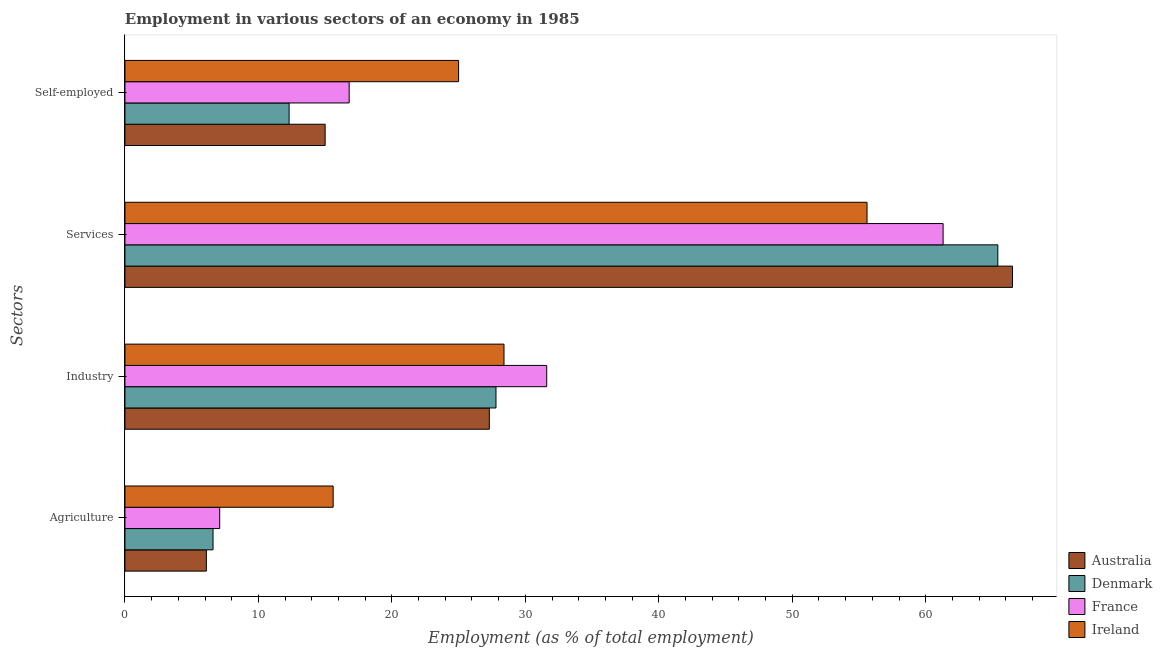How many different coloured bars are there?
Your answer should be very brief. 4. Are the number of bars per tick equal to the number of legend labels?
Make the answer very short. Yes. How many bars are there on the 2nd tick from the bottom?
Your response must be concise. 4. What is the label of the 3rd group of bars from the top?
Give a very brief answer. Industry. What is the percentage of self employed workers in Ireland?
Your answer should be very brief. 25. Across all countries, what is the maximum percentage of workers in services?
Give a very brief answer. 66.5. Across all countries, what is the minimum percentage of workers in services?
Keep it short and to the point. 55.6. What is the total percentage of workers in services in the graph?
Ensure brevity in your answer.  248.8. What is the difference between the percentage of workers in services in France and that in Australia?
Ensure brevity in your answer.  -5.2. What is the difference between the percentage of workers in industry in France and the percentage of workers in services in Denmark?
Provide a succinct answer. -33.8. What is the average percentage of workers in agriculture per country?
Your response must be concise. 8.85. What is the difference between the percentage of workers in services and percentage of workers in agriculture in Denmark?
Provide a succinct answer. 58.8. In how many countries, is the percentage of workers in industry greater than 30 %?
Offer a very short reply. 1. What is the ratio of the percentage of self employed workers in Ireland to that in France?
Make the answer very short. 1.49. What is the difference between the highest and the second highest percentage of self employed workers?
Offer a very short reply. 8.2. What is the difference between the highest and the lowest percentage of workers in agriculture?
Ensure brevity in your answer.  9.5. Is the sum of the percentage of workers in agriculture in Ireland and Australia greater than the maximum percentage of workers in industry across all countries?
Provide a succinct answer. No. Is it the case that in every country, the sum of the percentage of workers in industry and percentage of self employed workers is greater than the sum of percentage of workers in agriculture and percentage of workers in services?
Make the answer very short. No. What does the 3rd bar from the top in Industry represents?
Keep it short and to the point. Denmark. What does the 1st bar from the bottom in Agriculture represents?
Your answer should be compact. Australia. Is it the case that in every country, the sum of the percentage of workers in agriculture and percentage of workers in industry is greater than the percentage of workers in services?
Give a very brief answer. No. Are the values on the major ticks of X-axis written in scientific E-notation?
Keep it short and to the point. No. Does the graph contain any zero values?
Provide a succinct answer. No. Does the graph contain grids?
Your answer should be very brief. No. Where does the legend appear in the graph?
Your response must be concise. Bottom right. How many legend labels are there?
Keep it short and to the point. 4. How are the legend labels stacked?
Provide a succinct answer. Vertical. What is the title of the graph?
Your answer should be compact. Employment in various sectors of an economy in 1985. Does "Belize" appear as one of the legend labels in the graph?
Your answer should be compact. No. What is the label or title of the X-axis?
Your answer should be very brief. Employment (as % of total employment). What is the label or title of the Y-axis?
Offer a terse response. Sectors. What is the Employment (as % of total employment) in Australia in Agriculture?
Offer a terse response. 6.1. What is the Employment (as % of total employment) in Denmark in Agriculture?
Give a very brief answer. 6.6. What is the Employment (as % of total employment) of France in Agriculture?
Provide a succinct answer. 7.1. What is the Employment (as % of total employment) in Ireland in Agriculture?
Your response must be concise. 15.6. What is the Employment (as % of total employment) in Australia in Industry?
Offer a terse response. 27.3. What is the Employment (as % of total employment) in Denmark in Industry?
Provide a succinct answer. 27.8. What is the Employment (as % of total employment) of France in Industry?
Provide a short and direct response. 31.6. What is the Employment (as % of total employment) of Ireland in Industry?
Offer a terse response. 28.4. What is the Employment (as % of total employment) of Australia in Services?
Provide a short and direct response. 66.5. What is the Employment (as % of total employment) of Denmark in Services?
Give a very brief answer. 65.4. What is the Employment (as % of total employment) in France in Services?
Offer a terse response. 61.3. What is the Employment (as % of total employment) in Ireland in Services?
Ensure brevity in your answer.  55.6. What is the Employment (as % of total employment) in Australia in Self-employed?
Provide a short and direct response. 15. What is the Employment (as % of total employment) of Denmark in Self-employed?
Give a very brief answer. 12.3. What is the Employment (as % of total employment) in France in Self-employed?
Provide a short and direct response. 16.8. Across all Sectors, what is the maximum Employment (as % of total employment) in Australia?
Your answer should be very brief. 66.5. Across all Sectors, what is the maximum Employment (as % of total employment) of Denmark?
Keep it short and to the point. 65.4. Across all Sectors, what is the maximum Employment (as % of total employment) of France?
Provide a short and direct response. 61.3. Across all Sectors, what is the maximum Employment (as % of total employment) of Ireland?
Your answer should be very brief. 55.6. Across all Sectors, what is the minimum Employment (as % of total employment) of Australia?
Keep it short and to the point. 6.1. Across all Sectors, what is the minimum Employment (as % of total employment) of Denmark?
Ensure brevity in your answer.  6.6. Across all Sectors, what is the minimum Employment (as % of total employment) of France?
Offer a very short reply. 7.1. Across all Sectors, what is the minimum Employment (as % of total employment) in Ireland?
Make the answer very short. 15.6. What is the total Employment (as % of total employment) in Australia in the graph?
Offer a terse response. 114.9. What is the total Employment (as % of total employment) in Denmark in the graph?
Give a very brief answer. 112.1. What is the total Employment (as % of total employment) of France in the graph?
Provide a succinct answer. 116.8. What is the total Employment (as % of total employment) of Ireland in the graph?
Your answer should be compact. 124.6. What is the difference between the Employment (as % of total employment) in Australia in Agriculture and that in Industry?
Keep it short and to the point. -21.2. What is the difference between the Employment (as % of total employment) of Denmark in Agriculture and that in Industry?
Ensure brevity in your answer.  -21.2. What is the difference between the Employment (as % of total employment) in France in Agriculture and that in Industry?
Ensure brevity in your answer.  -24.5. What is the difference between the Employment (as % of total employment) of Australia in Agriculture and that in Services?
Make the answer very short. -60.4. What is the difference between the Employment (as % of total employment) of Denmark in Agriculture and that in Services?
Provide a short and direct response. -58.8. What is the difference between the Employment (as % of total employment) of France in Agriculture and that in Services?
Your answer should be very brief. -54.2. What is the difference between the Employment (as % of total employment) of Ireland in Agriculture and that in Services?
Make the answer very short. -40. What is the difference between the Employment (as % of total employment) of Australia in Agriculture and that in Self-employed?
Give a very brief answer. -8.9. What is the difference between the Employment (as % of total employment) in Australia in Industry and that in Services?
Offer a terse response. -39.2. What is the difference between the Employment (as % of total employment) in Denmark in Industry and that in Services?
Offer a terse response. -37.6. What is the difference between the Employment (as % of total employment) of France in Industry and that in Services?
Give a very brief answer. -29.7. What is the difference between the Employment (as % of total employment) of Ireland in Industry and that in Services?
Give a very brief answer. -27.2. What is the difference between the Employment (as % of total employment) of Denmark in Industry and that in Self-employed?
Ensure brevity in your answer.  15.5. What is the difference between the Employment (as % of total employment) in Australia in Services and that in Self-employed?
Your answer should be very brief. 51.5. What is the difference between the Employment (as % of total employment) of Denmark in Services and that in Self-employed?
Your answer should be compact. 53.1. What is the difference between the Employment (as % of total employment) of France in Services and that in Self-employed?
Provide a short and direct response. 44.5. What is the difference between the Employment (as % of total employment) of Ireland in Services and that in Self-employed?
Provide a succinct answer. 30.6. What is the difference between the Employment (as % of total employment) of Australia in Agriculture and the Employment (as % of total employment) of Denmark in Industry?
Provide a succinct answer. -21.7. What is the difference between the Employment (as % of total employment) in Australia in Agriculture and the Employment (as % of total employment) in France in Industry?
Your answer should be compact. -25.5. What is the difference between the Employment (as % of total employment) of Australia in Agriculture and the Employment (as % of total employment) of Ireland in Industry?
Offer a very short reply. -22.3. What is the difference between the Employment (as % of total employment) in Denmark in Agriculture and the Employment (as % of total employment) in Ireland in Industry?
Your answer should be compact. -21.8. What is the difference between the Employment (as % of total employment) of France in Agriculture and the Employment (as % of total employment) of Ireland in Industry?
Your answer should be compact. -21.3. What is the difference between the Employment (as % of total employment) of Australia in Agriculture and the Employment (as % of total employment) of Denmark in Services?
Make the answer very short. -59.3. What is the difference between the Employment (as % of total employment) of Australia in Agriculture and the Employment (as % of total employment) of France in Services?
Provide a succinct answer. -55.2. What is the difference between the Employment (as % of total employment) in Australia in Agriculture and the Employment (as % of total employment) in Ireland in Services?
Keep it short and to the point. -49.5. What is the difference between the Employment (as % of total employment) in Denmark in Agriculture and the Employment (as % of total employment) in France in Services?
Give a very brief answer. -54.7. What is the difference between the Employment (as % of total employment) in Denmark in Agriculture and the Employment (as % of total employment) in Ireland in Services?
Offer a terse response. -49. What is the difference between the Employment (as % of total employment) of France in Agriculture and the Employment (as % of total employment) of Ireland in Services?
Provide a short and direct response. -48.5. What is the difference between the Employment (as % of total employment) of Australia in Agriculture and the Employment (as % of total employment) of Ireland in Self-employed?
Ensure brevity in your answer.  -18.9. What is the difference between the Employment (as % of total employment) in Denmark in Agriculture and the Employment (as % of total employment) in France in Self-employed?
Ensure brevity in your answer.  -10.2. What is the difference between the Employment (as % of total employment) of Denmark in Agriculture and the Employment (as % of total employment) of Ireland in Self-employed?
Give a very brief answer. -18.4. What is the difference between the Employment (as % of total employment) of France in Agriculture and the Employment (as % of total employment) of Ireland in Self-employed?
Your answer should be very brief. -17.9. What is the difference between the Employment (as % of total employment) of Australia in Industry and the Employment (as % of total employment) of Denmark in Services?
Give a very brief answer. -38.1. What is the difference between the Employment (as % of total employment) of Australia in Industry and the Employment (as % of total employment) of France in Services?
Keep it short and to the point. -34. What is the difference between the Employment (as % of total employment) in Australia in Industry and the Employment (as % of total employment) in Ireland in Services?
Offer a very short reply. -28.3. What is the difference between the Employment (as % of total employment) of Denmark in Industry and the Employment (as % of total employment) of France in Services?
Your answer should be compact. -33.5. What is the difference between the Employment (as % of total employment) of Denmark in Industry and the Employment (as % of total employment) of Ireland in Services?
Your answer should be compact. -27.8. What is the difference between the Employment (as % of total employment) of France in Industry and the Employment (as % of total employment) of Ireland in Services?
Your response must be concise. -24. What is the difference between the Employment (as % of total employment) of Australia in Industry and the Employment (as % of total employment) of France in Self-employed?
Your answer should be compact. 10.5. What is the difference between the Employment (as % of total employment) of Denmark in Industry and the Employment (as % of total employment) of Ireland in Self-employed?
Provide a succinct answer. 2.8. What is the difference between the Employment (as % of total employment) in Australia in Services and the Employment (as % of total employment) in Denmark in Self-employed?
Your answer should be very brief. 54.2. What is the difference between the Employment (as % of total employment) in Australia in Services and the Employment (as % of total employment) in France in Self-employed?
Provide a short and direct response. 49.7. What is the difference between the Employment (as % of total employment) in Australia in Services and the Employment (as % of total employment) in Ireland in Self-employed?
Your answer should be compact. 41.5. What is the difference between the Employment (as % of total employment) in Denmark in Services and the Employment (as % of total employment) in France in Self-employed?
Ensure brevity in your answer.  48.6. What is the difference between the Employment (as % of total employment) in Denmark in Services and the Employment (as % of total employment) in Ireland in Self-employed?
Your answer should be very brief. 40.4. What is the difference between the Employment (as % of total employment) in France in Services and the Employment (as % of total employment) in Ireland in Self-employed?
Make the answer very short. 36.3. What is the average Employment (as % of total employment) of Australia per Sectors?
Keep it short and to the point. 28.73. What is the average Employment (as % of total employment) of Denmark per Sectors?
Keep it short and to the point. 28.02. What is the average Employment (as % of total employment) of France per Sectors?
Make the answer very short. 29.2. What is the average Employment (as % of total employment) in Ireland per Sectors?
Offer a terse response. 31.15. What is the difference between the Employment (as % of total employment) of Australia and Employment (as % of total employment) of Denmark in Agriculture?
Your answer should be very brief. -0.5. What is the difference between the Employment (as % of total employment) of Australia and Employment (as % of total employment) of Ireland in Agriculture?
Your answer should be compact. -9.5. What is the difference between the Employment (as % of total employment) of Australia and Employment (as % of total employment) of France in Industry?
Your response must be concise. -4.3. What is the difference between the Employment (as % of total employment) in Australia and Employment (as % of total employment) in Ireland in Industry?
Keep it short and to the point. -1.1. What is the difference between the Employment (as % of total employment) of Denmark and Employment (as % of total employment) of France in Industry?
Give a very brief answer. -3.8. What is the difference between the Employment (as % of total employment) in Denmark and Employment (as % of total employment) in Ireland in Industry?
Provide a short and direct response. -0.6. What is the difference between the Employment (as % of total employment) of Australia and Employment (as % of total employment) of Denmark in Services?
Your response must be concise. 1.1. What is the difference between the Employment (as % of total employment) of Australia and Employment (as % of total employment) of Ireland in Services?
Your response must be concise. 10.9. What is the difference between the Employment (as % of total employment) in Denmark and Employment (as % of total employment) in Ireland in Services?
Make the answer very short. 9.8. What is the difference between the Employment (as % of total employment) of Australia and Employment (as % of total employment) of Denmark in Self-employed?
Offer a terse response. 2.7. What is the difference between the Employment (as % of total employment) of Australia and Employment (as % of total employment) of France in Self-employed?
Provide a succinct answer. -1.8. What is the difference between the Employment (as % of total employment) of Denmark and Employment (as % of total employment) of France in Self-employed?
Offer a terse response. -4.5. What is the ratio of the Employment (as % of total employment) of Australia in Agriculture to that in Industry?
Ensure brevity in your answer.  0.22. What is the ratio of the Employment (as % of total employment) of Denmark in Agriculture to that in Industry?
Provide a succinct answer. 0.24. What is the ratio of the Employment (as % of total employment) in France in Agriculture to that in Industry?
Your answer should be very brief. 0.22. What is the ratio of the Employment (as % of total employment) in Ireland in Agriculture to that in Industry?
Your answer should be compact. 0.55. What is the ratio of the Employment (as % of total employment) in Australia in Agriculture to that in Services?
Give a very brief answer. 0.09. What is the ratio of the Employment (as % of total employment) in Denmark in Agriculture to that in Services?
Keep it short and to the point. 0.1. What is the ratio of the Employment (as % of total employment) in France in Agriculture to that in Services?
Provide a succinct answer. 0.12. What is the ratio of the Employment (as % of total employment) of Ireland in Agriculture to that in Services?
Make the answer very short. 0.28. What is the ratio of the Employment (as % of total employment) in Australia in Agriculture to that in Self-employed?
Provide a short and direct response. 0.41. What is the ratio of the Employment (as % of total employment) of Denmark in Agriculture to that in Self-employed?
Keep it short and to the point. 0.54. What is the ratio of the Employment (as % of total employment) in France in Agriculture to that in Self-employed?
Your response must be concise. 0.42. What is the ratio of the Employment (as % of total employment) in Ireland in Agriculture to that in Self-employed?
Your answer should be compact. 0.62. What is the ratio of the Employment (as % of total employment) of Australia in Industry to that in Services?
Provide a short and direct response. 0.41. What is the ratio of the Employment (as % of total employment) of Denmark in Industry to that in Services?
Give a very brief answer. 0.43. What is the ratio of the Employment (as % of total employment) of France in Industry to that in Services?
Your answer should be compact. 0.52. What is the ratio of the Employment (as % of total employment) in Ireland in Industry to that in Services?
Make the answer very short. 0.51. What is the ratio of the Employment (as % of total employment) of Australia in Industry to that in Self-employed?
Offer a terse response. 1.82. What is the ratio of the Employment (as % of total employment) of Denmark in Industry to that in Self-employed?
Give a very brief answer. 2.26. What is the ratio of the Employment (as % of total employment) of France in Industry to that in Self-employed?
Your response must be concise. 1.88. What is the ratio of the Employment (as % of total employment) of Ireland in Industry to that in Self-employed?
Your answer should be very brief. 1.14. What is the ratio of the Employment (as % of total employment) in Australia in Services to that in Self-employed?
Keep it short and to the point. 4.43. What is the ratio of the Employment (as % of total employment) of Denmark in Services to that in Self-employed?
Give a very brief answer. 5.32. What is the ratio of the Employment (as % of total employment) in France in Services to that in Self-employed?
Provide a succinct answer. 3.65. What is the ratio of the Employment (as % of total employment) of Ireland in Services to that in Self-employed?
Give a very brief answer. 2.22. What is the difference between the highest and the second highest Employment (as % of total employment) in Australia?
Your answer should be very brief. 39.2. What is the difference between the highest and the second highest Employment (as % of total employment) in Denmark?
Give a very brief answer. 37.6. What is the difference between the highest and the second highest Employment (as % of total employment) in France?
Keep it short and to the point. 29.7. What is the difference between the highest and the second highest Employment (as % of total employment) in Ireland?
Offer a very short reply. 27.2. What is the difference between the highest and the lowest Employment (as % of total employment) in Australia?
Offer a very short reply. 60.4. What is the difference between the highest and the lowest Employment (as % of total employment) of Denmark?
Offer a terse response. 58.8. What is the difference between the highest and the lowest Employment (as % of total employment) of France?
Your answer should be compact. 54.2. 